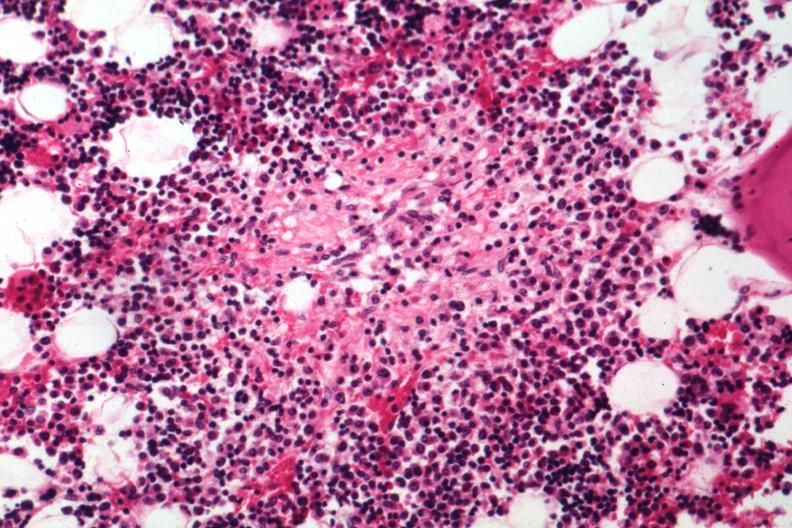what is present?
Answer the question using a single word or phrase. Tuberculosis 